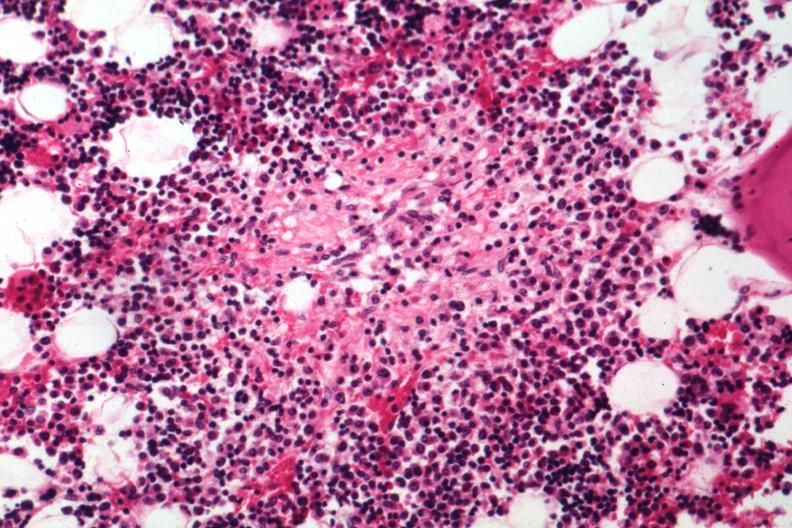what is present?
Answer the question using a single word or phrase. Tuberculosis 